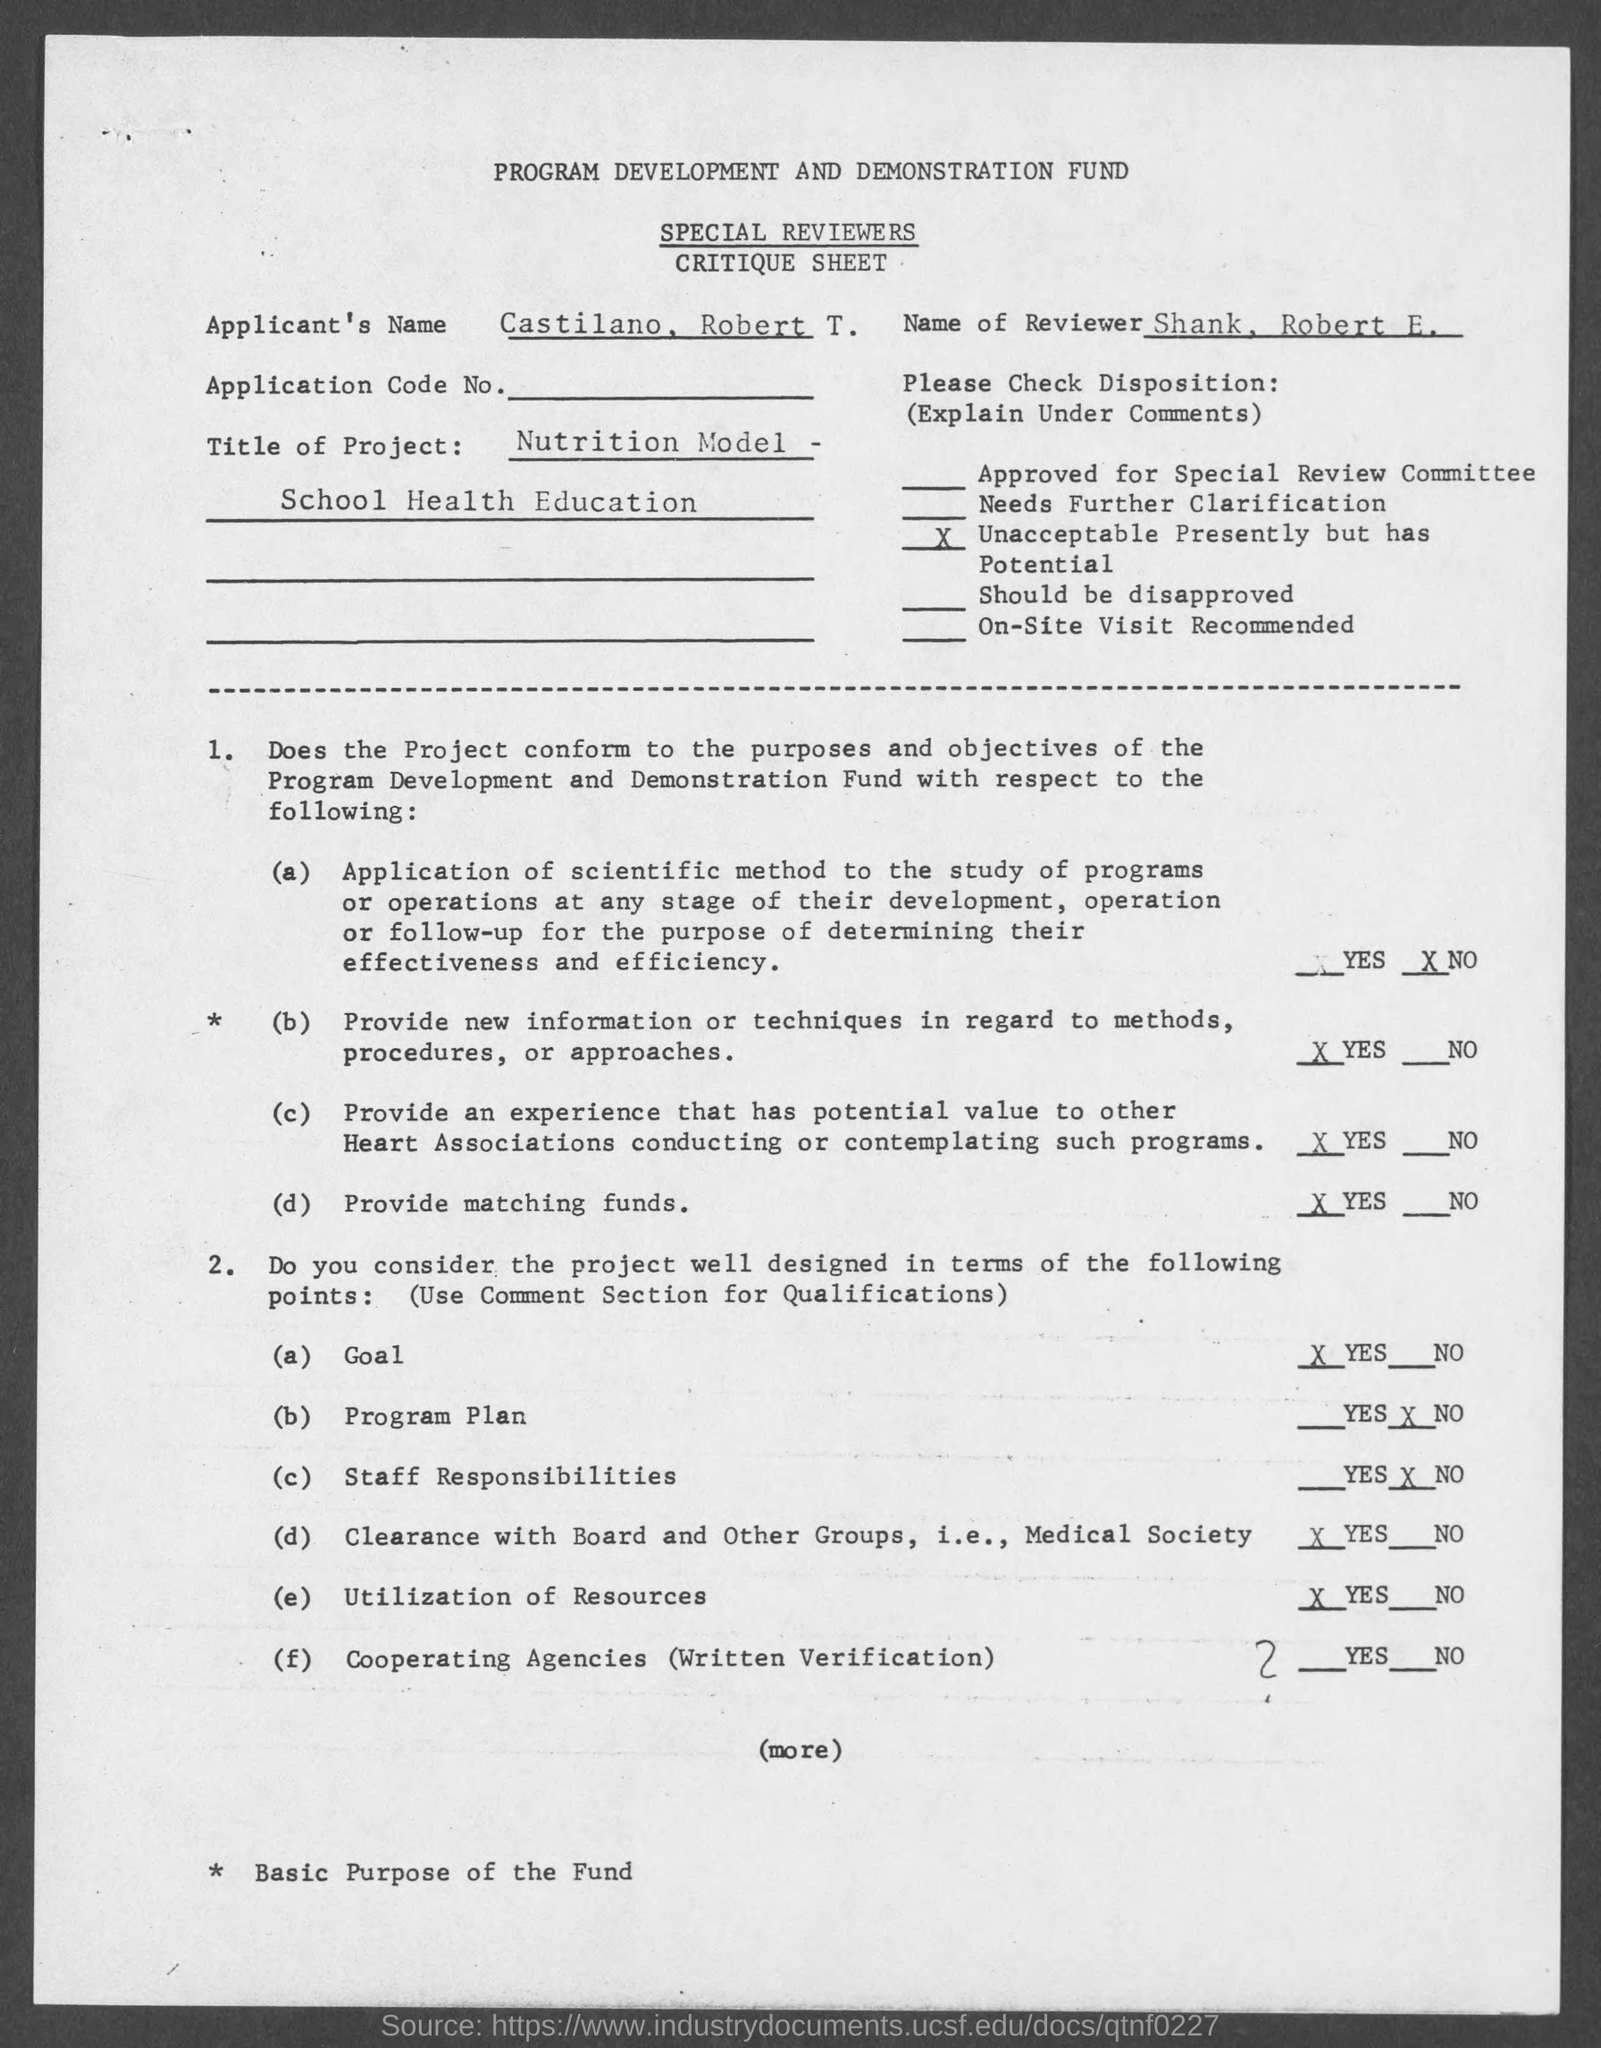What is the Applicant's Name?
Your answer should be compact. Castilano, Robert T. What is the Name of Reviewer?
Offer a terse response. Shank, robert e. 